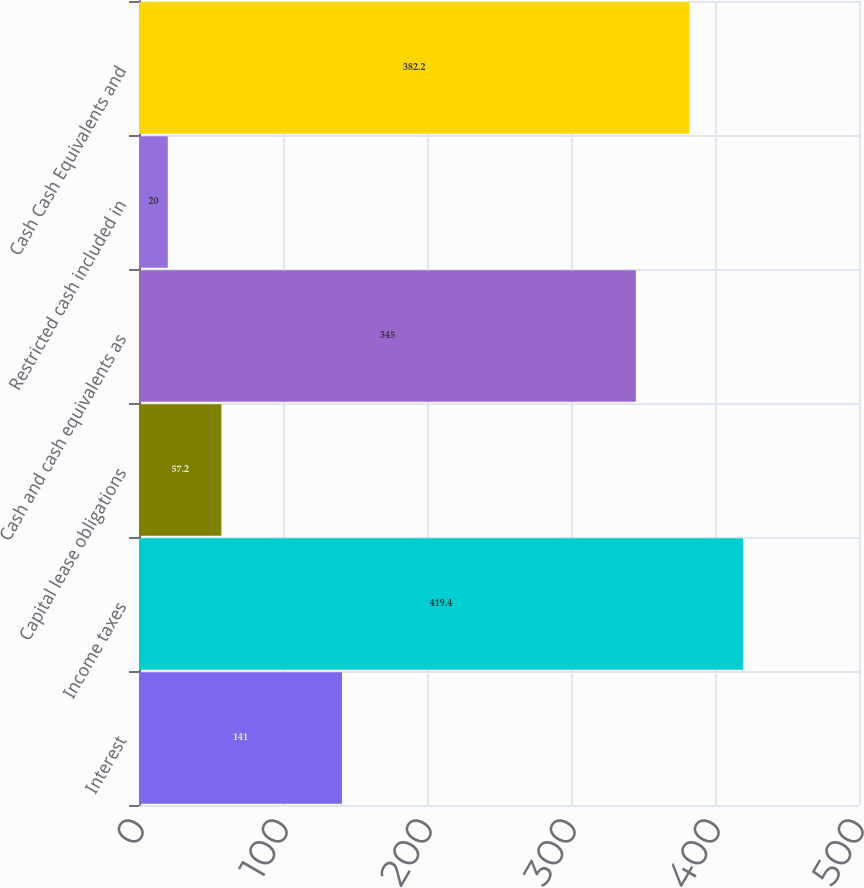Convert chart. <chart><loc_0><loc_0><loc_500><loc_500><bar_chart><fcel>Interest<fcel>Income taxes<fcel>Capital lease obligations<fcel>Cash and cash equivalents as<fcel>Restricted cash included in<fcel>Cash Cash Equivalents and<nl><fcel>141<fcel>419.4<fcel>57.2<fcel>345<fcel>20<fcel>382.2<nl></chart> 